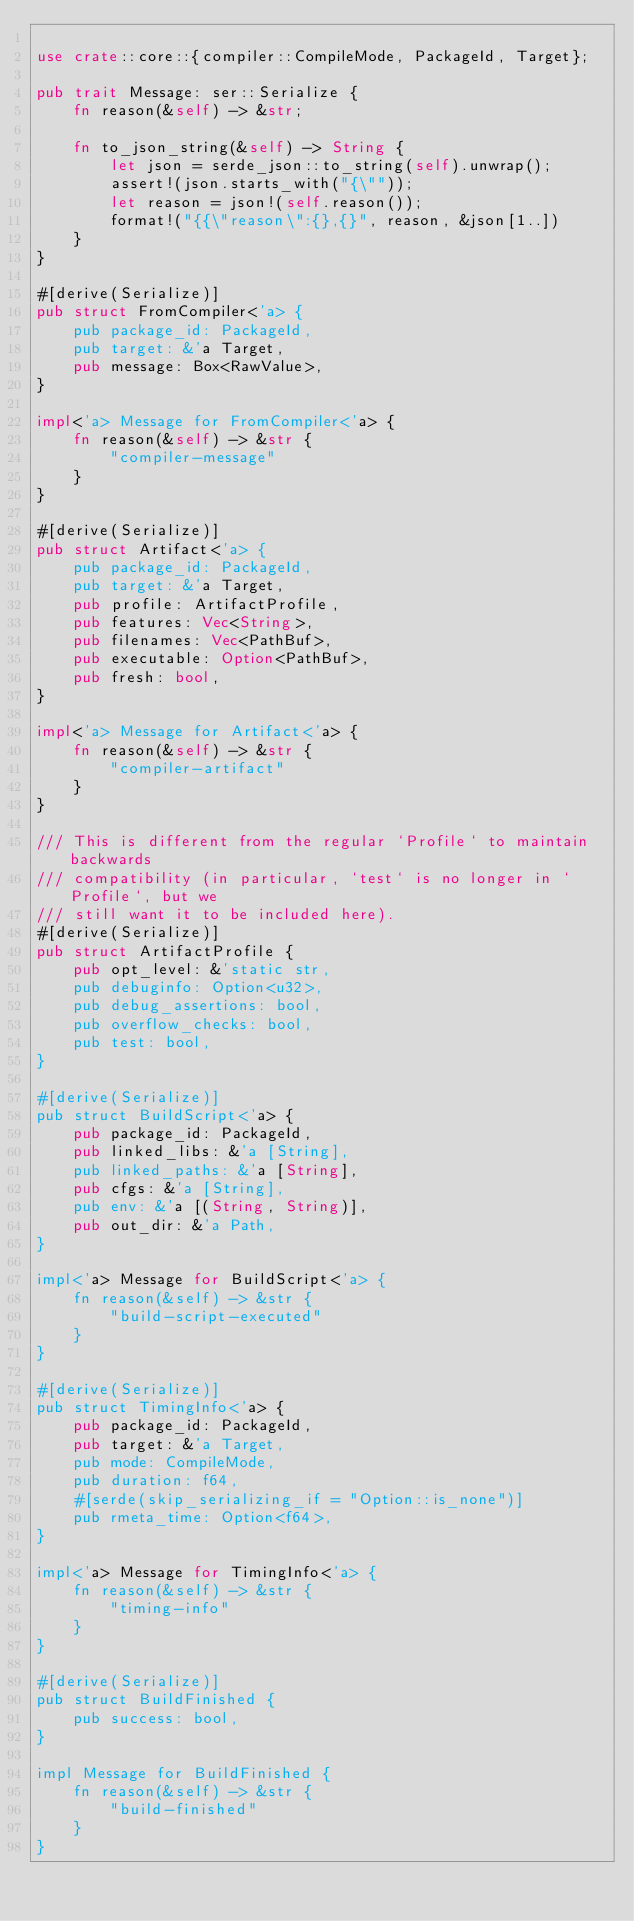Convert code to text. <code><loc_0><loc_0><loc_500><loc_500><_Rust_>
use crate::core::{compiler::CompileMode, PackageId, Target};

pub trait Message: ser::Serialize {
    fn reason(&self) -> &str;

    fn to_json_string(&self) -> String {
        let json = serde_json::to_string(self).unwrap();
        assert!(json.starts_with("{\""));
        let reason = json!(self.reason());
        format!("{{\"reason\":{},{}", reason, &json[1..])
    }
}

#[derive(Serialize)]
pub struct FromCompiler<'a> {
    pub package_id: PackageId,
    pub target: &'a Target,
    pub message: Box<RawValue>,
}

impl<'a> Message for FromCompiler<'a> {
    fn reason(&self) -> &str {
        "compiler-message"
    }
}

#[derive(Serialize)]
pub struct Artifact<'a> {
    pub package_id: PackageId,
    pub target: &'a Target,
    pub profile: ArtifactProfile,
    pub features: Vec<String>,
    pub filenames: Vec<PathBuf>,
    pub executable: Option<PathBuf>,
    pub fresh: bool,
}

impl<'a> Message for Artifact<'a> {
    fn reason(&self) -> &str {
        "compiler-artifact"
    }
}

/// This is different from the regular `Profile` to maintain backwards
/// compatibility (in particular, `test` is no longer in `Profile`, but we
/// still want it to be included here).
#[derive(Serialize)]
pub struct ArtifactProfile {
    pub opt_level: &'static str,
    pub debuginfo: Option<u32>,
    pub debug_assertions: bool,
    pub overflow_checks: bool,
    pub test: bool,
}

#[derive(Serialize)]
pub struct BuildScript<'a> {
    pub package_id: PackageId,
    pub linked_libs: &'a [String],
    pub linked_paths: &'a [String],
    pub cfgs: &'a [String],
    pub env: &'a [(String, String)],
    pub out_dir: &'a Path,
}

impl<'a> Message for BuildScript<'a> {
    fn reason(&self) -> &str {
        "build-script-executed"
    }
}

#[derive(Serialize)]
pub struct TimingInfo<'a> {
    pub package_id: PackageId,
    pub target: &'a Target,
    pub mode: CompileMode,
    pub duration: f64,
    #[serde(skip_serializing_if = "Option::is_none")]
    pub rmeta_time: Option<f64>,
}

impl<'a> Message for TimingInfo<'a> {
    fn reason(&self) -> &str {
        "timing-info"
    }
}

#[derive(Serialize)]
pub struct BuildFinished {
    pub success: bool,
}

impl Message for BuildFinished {
    fn reason(&self) -> &str {
        "build-finished"
    }
}
</code> 